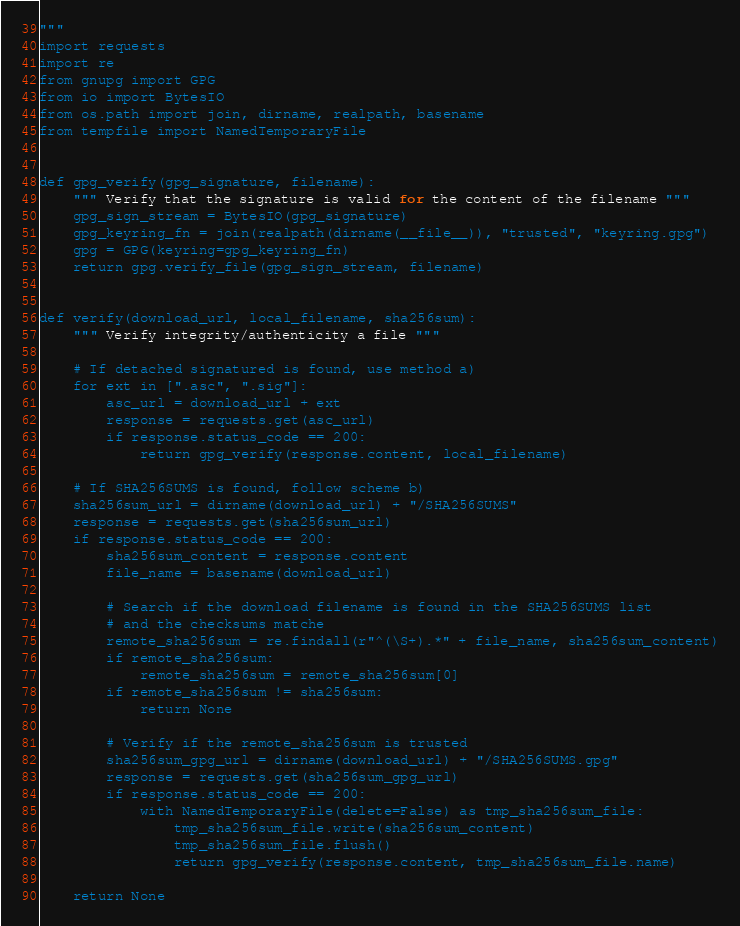<code> <loc_0><loc_0><loc_500><loc_500><_Python_>"""
import requests
import re
from gnupg import GPG
from io import BytesIO
from os.path import join, dirname, realpath, basename
from tempfile import NamedTemporaryFile


def gpg_verify(gpg_signature, filename):
    """ Verify that the signature is valid for the content of the filename """
    gpg_sign_stream = BytesIO(gpg_signature)
    gpg_keyring_fn = join(realpath(dirname(__file__)), "trusted", "keyring.gpg")
    gpg = GPG(keyring=gpg_keyring_fn)
    return gpg.verify_file(gpg_sign_stream, filename)


def verify(download_url, local_filename, sha256sum):
    """ Verify integrity/authenticity a file """

    # If detached signatured is found, use method a)
    for ext in [".asc", ".sig"]:
        asc_url = download_url + ext
        response = requests.get(asc_url)
        if response.status_code == 200:
            return gpg_verify(response.content, local_filename)

    # If SHA256SUMS is found, follow scheme b)
    sha256sum_url = dirname(download_url) + "/SHA256SUMS"
    response = requests.get(sha256sum_url)
    if response.status_code == 200:
        sha256sum_content = response.content
        file_name = basename(download_url)

        # Search if the download filename is found in the SHA256SUMS list
        # and the checksums matche
        remote_sha256sum = re.findall(r"^(\S+).*" + file_name, sha256sum_content)
        if remote_sha256sum:
            remote_sha256sum = remote_sha256sum[0]
        if remote_sha256sum != sha256sum:
            return None

        # Verify if the remote_sha256sum is trusted
        sha256sum_gpg_url = dirname(download_url) + "/SHA256SUMS.gpg"
        response = requests.get(sha256sum_gpg_url)
        if response.status_code == 200:
            with NamedTemporaryFile(delete=False) as tmp_sha256sum_file:
                tmp_sha256sum_file.write(sha256sum_content)
                tmp_sha256sum_file.flush()
                return gpg_verify(response.content, tmp_sha256sum_file.name)

    return None
</code> 